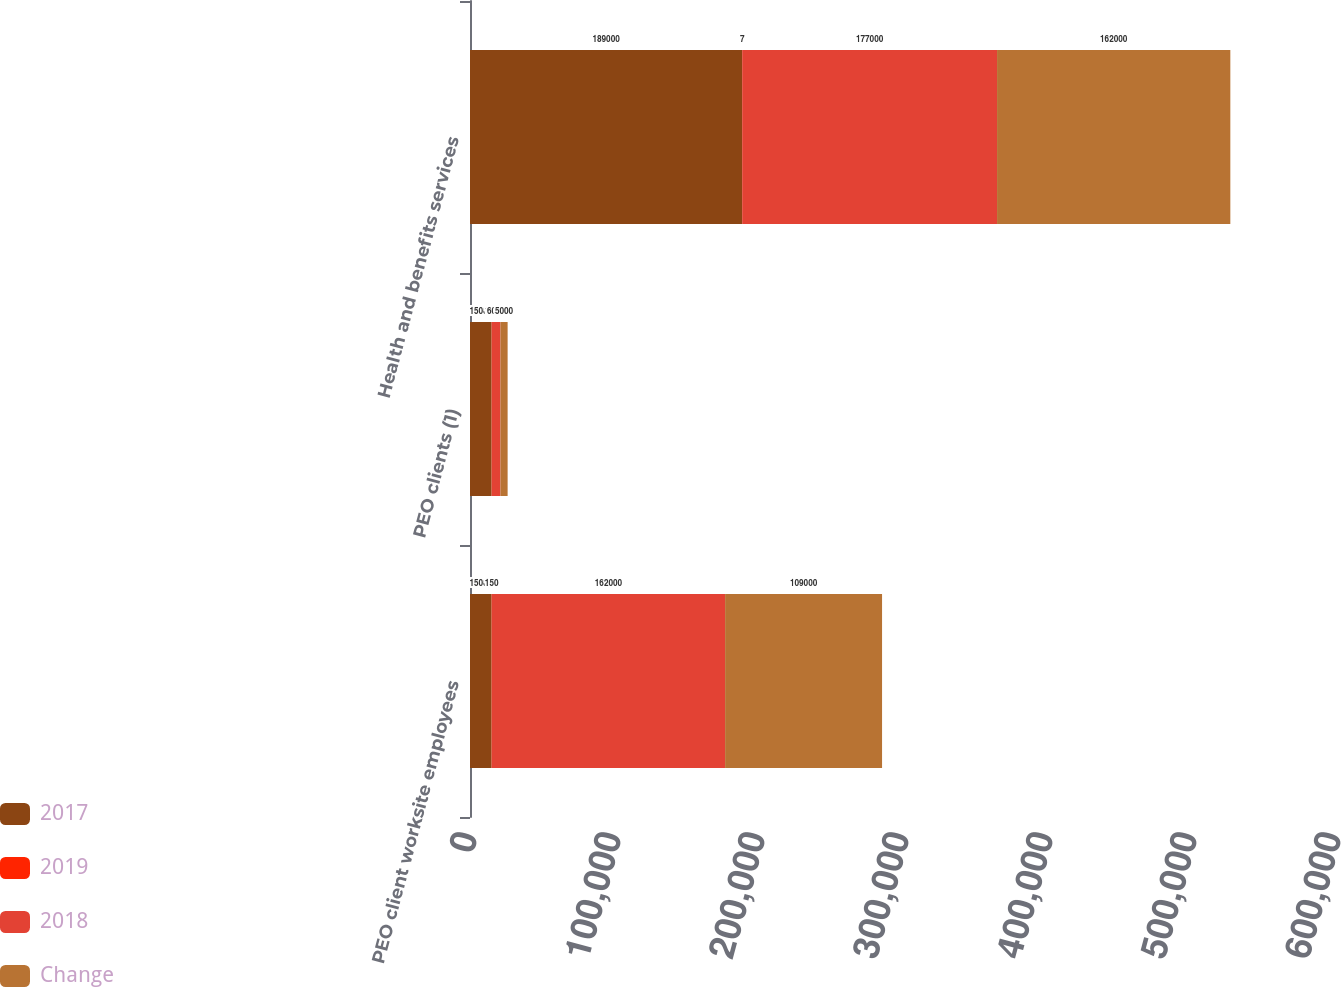Convert chart to OTSL. <chart><loc_0><loc_0><loc_500><loc_500><stacked_bar_chart><ecel><fcel>PEO client worksite employees<fcel>PEO clients (1)<fcel>Health and benefits services<nl><fcel>2017<fcel>15000<fcel>15000<fcel>189000<nl><fcel>2019<fcel>150<fcel>126<fcel>7<nl><fcel>2018<fcel>162000<fcel>6000<fcel>177000<nl><fcel>Change<fcel>109000<fcel>5000<fcel>162000<nl></chart> 